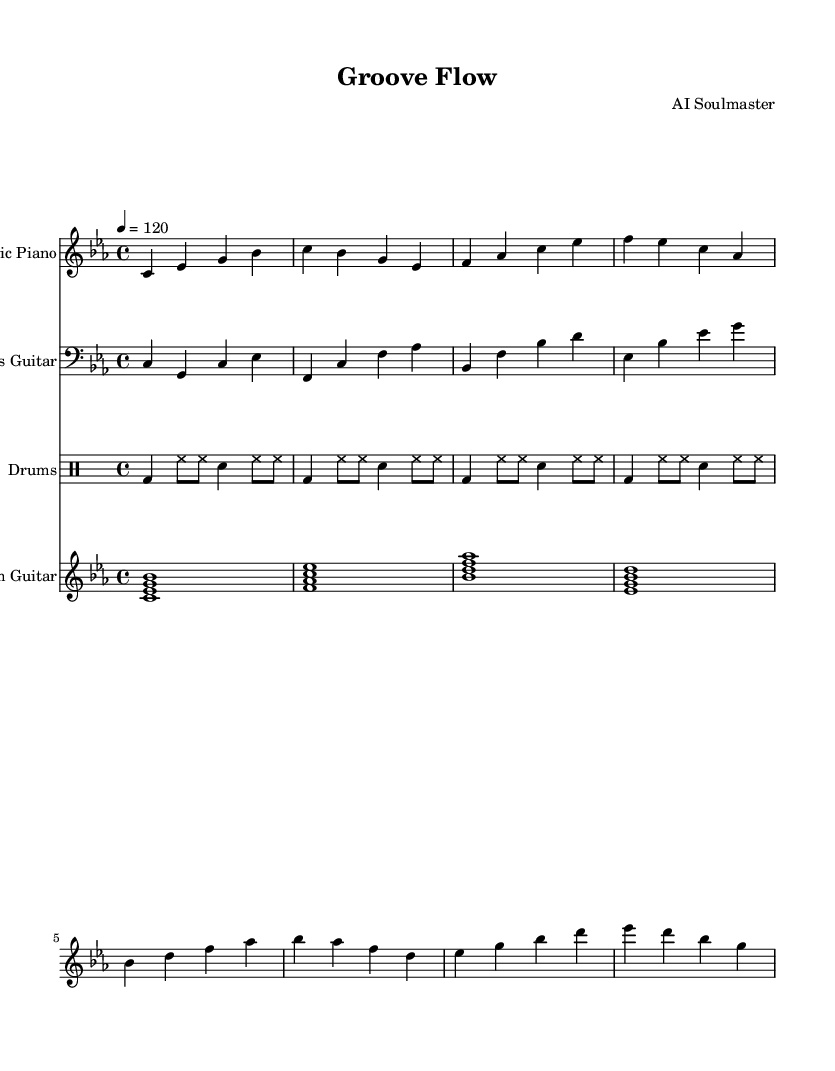What is the key signature of this music? The key signature is C minor, indicated by three flat notes: B flat, E flat, and A flat.
Answer: C minor What is the time signature of this music? The time signature is 4/4, which is shown at the beginning of the sheet music and indicates four beats per measure.
Answer: 4/4 What is the tempo marking of the piece? The tempo marking indicates a speed of 120 beats per minute, specified as "4 = 120" in the score.
Answer: 120 How many measures are in the electric piano part? The electric piano part consists of eight measures, identified by the grouping of notes and bar lines in the staff.
Answer: 8 Which instrument has the first entry in the score? The first entry in the score is the electric piano, as it is presented before the other instruments in the score layout.
Answer: Electric Piano What is the primary function of the rhythm guitar in this piece? The rhythm guitar provides harmonic support by playing chord voicings that complement the other instruments' lines, typically marking the beat with sustained chords.
Answer: Harmonic support How does the drum pattern contribute to the overall feel of the music? The drum pattern, characterized by a consistent kick and snare rhythm combined with steady hi-hat eighth notes, creates a groovy and driving feel typical of funky soul music.
Answer: Groovy feel 